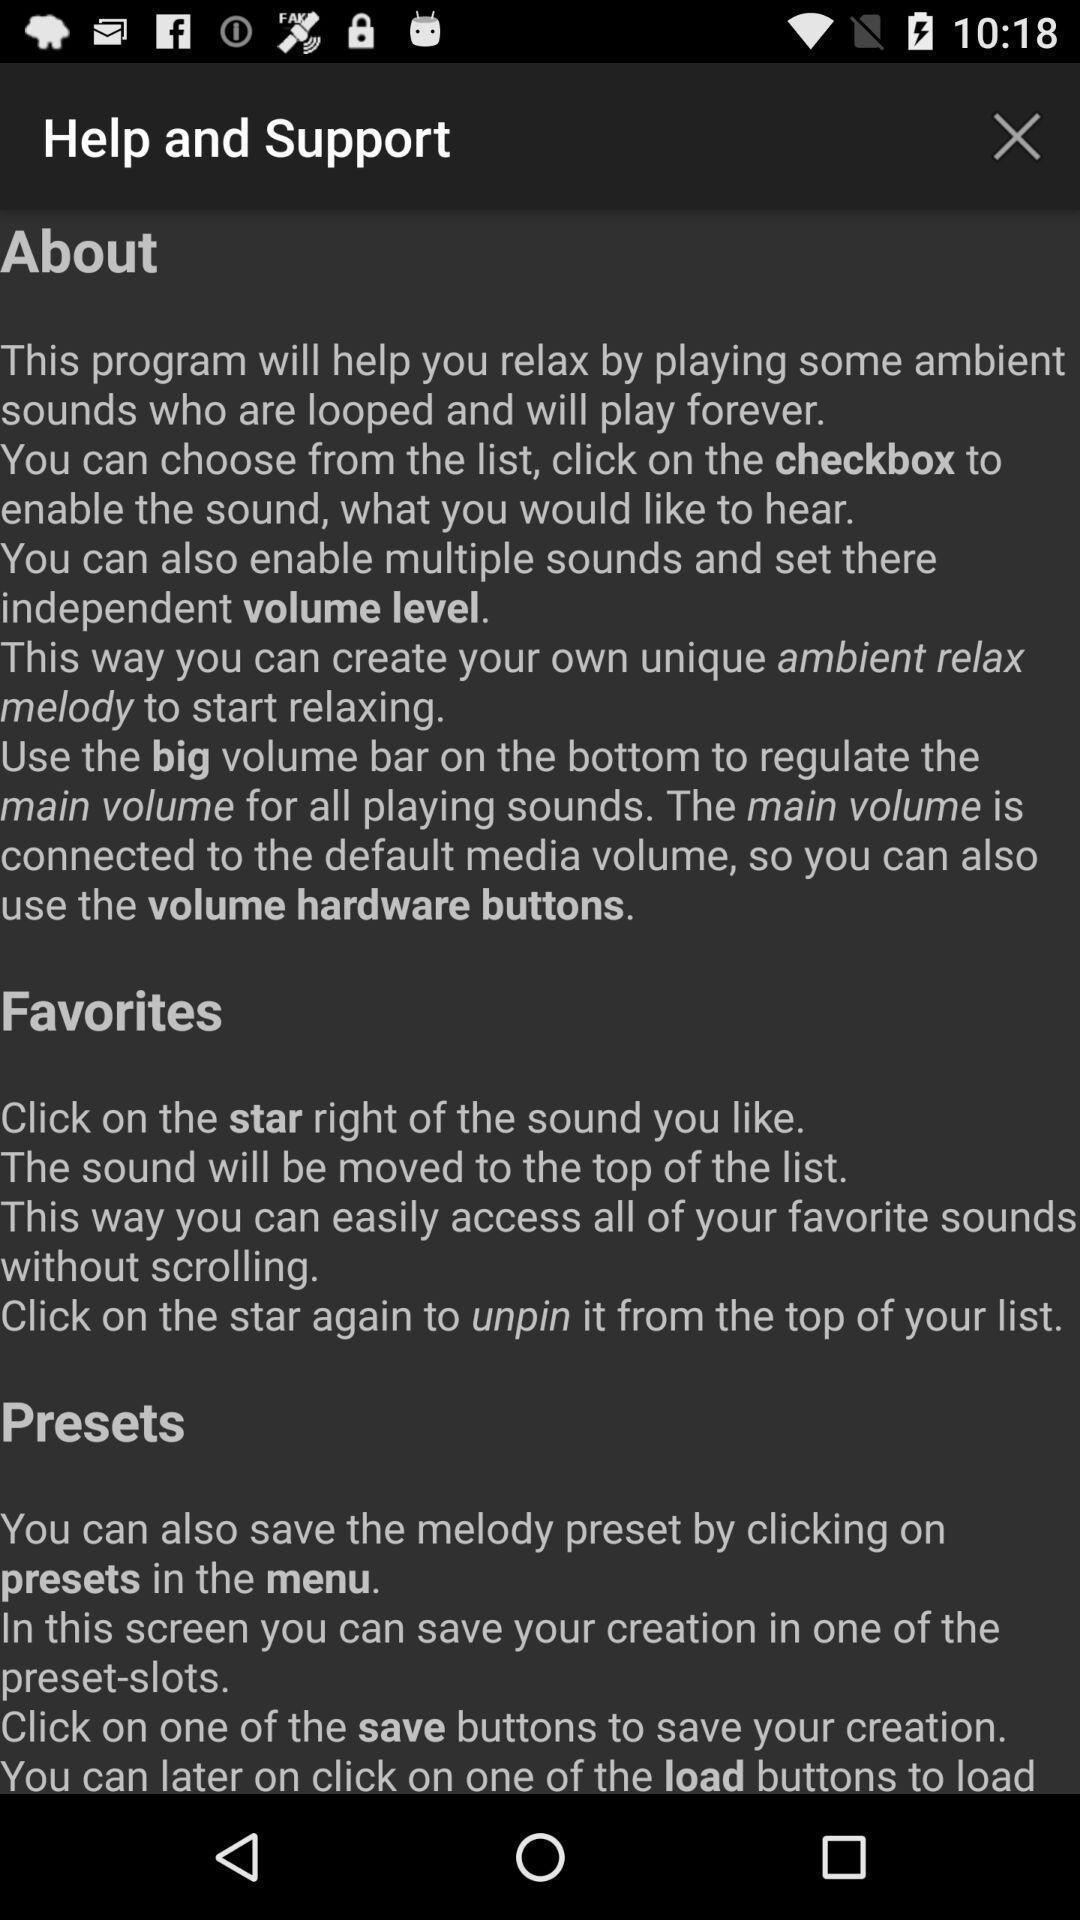Please provide a description for this image. Page displaying details about help and support on an app. 